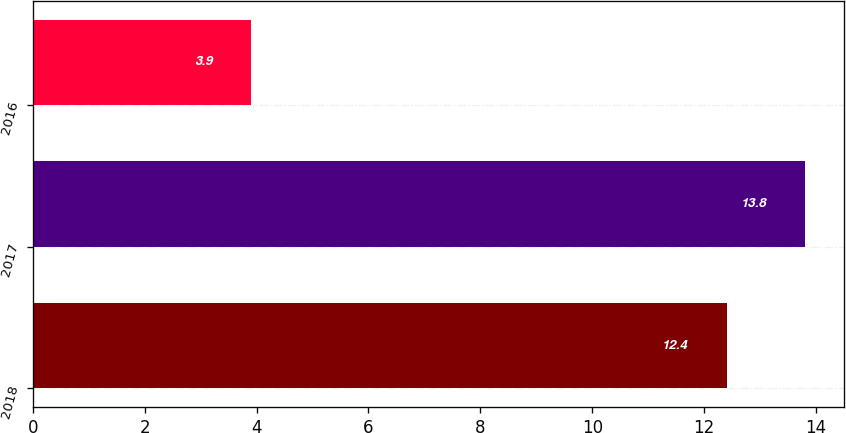<chart> <loc_0><loc_0><loc_500><loc_500><bar_chart><fcel>2018<fcel>2017<fcel>2016<nl><fcel>12.4<fcel>13.8<fcel>3.9<nl></chart> 